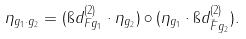<formula> <loc_0><loc_0><loc_500><loc_500>\eta _ { g _ { 1 } \cdot g _ { 2 } } = ( \i d ^ { ( 2 ) } _ { F g _ { 1 } } \cdot \eta _ { g _ { 2 } } ) \circ ( \eta _ { g _ { 1 } } \cdot \i d ^ { ( 2 ) } _ { \tilde { F } g _ { 2 } } ) .</formula> 